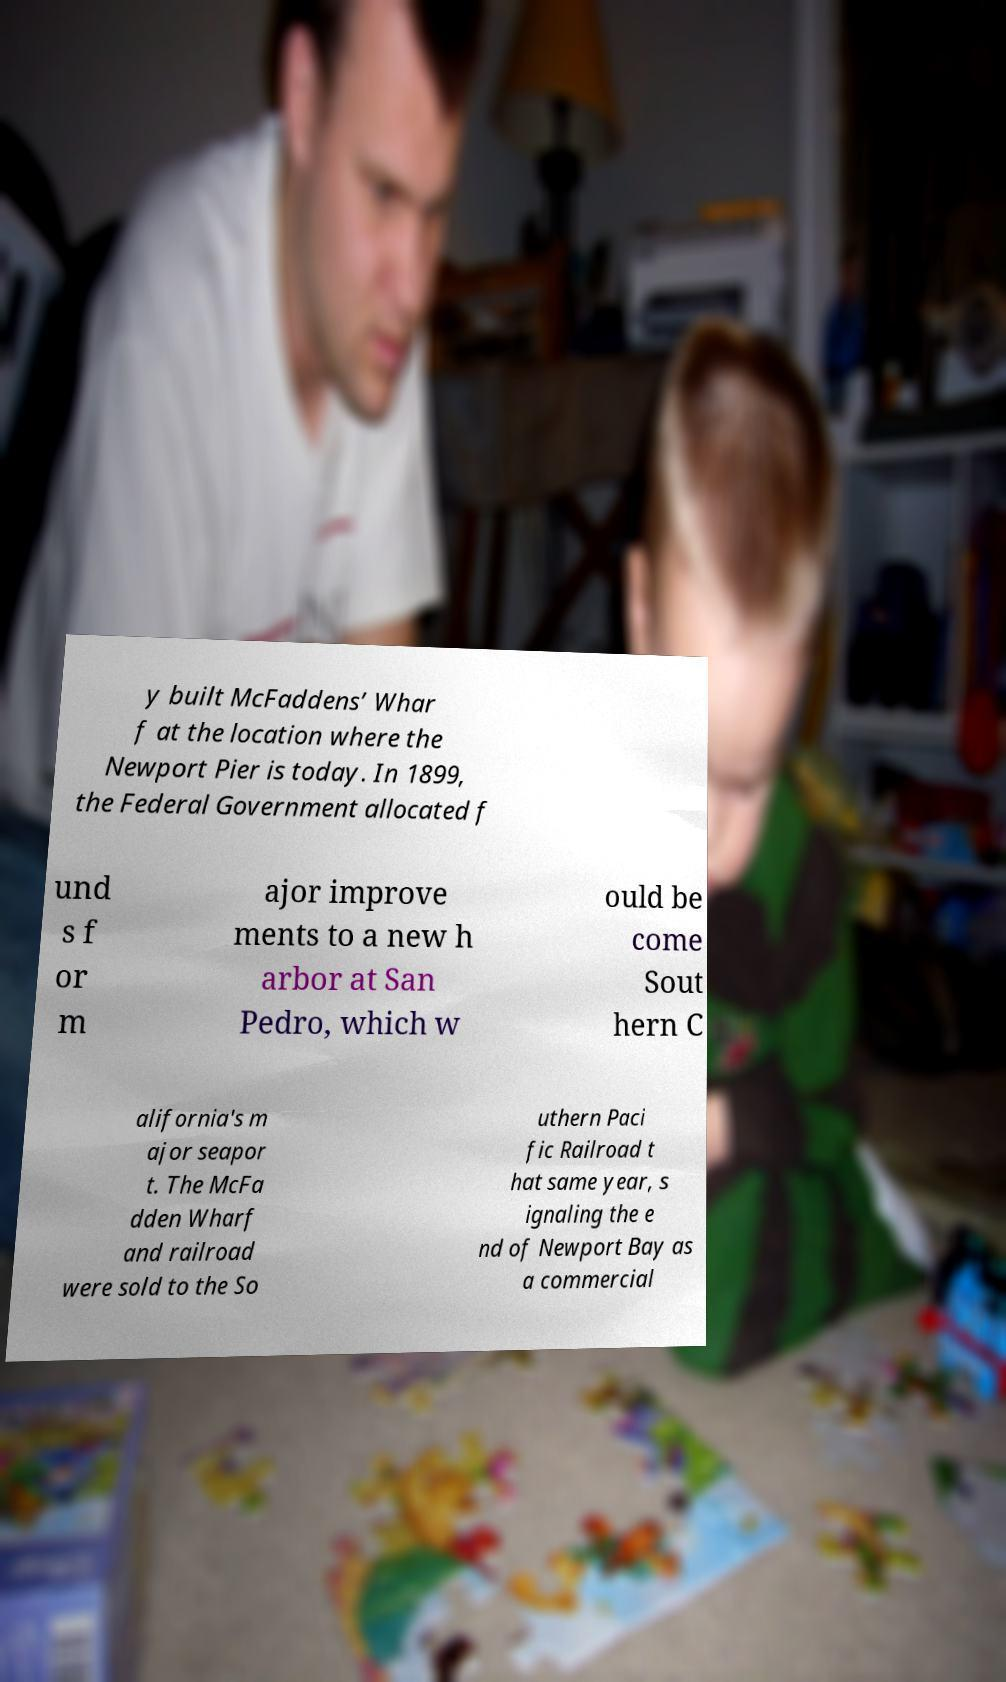There's text embedded in this image that I need extracted. Can you transcribe it verbatim? y built McFaddens’ Whar f at the location where the Newport Pier is today. In 1899, the Federal Government allocated f und s f or m ajor improve ments to a new h arbor at San Pedro, which w ould be come Sout hern C alifornia's m ajor seapor t. The McFa dden Wharf and railroad were sold to the So uthern Paci fic Railroad t hat same year, s ignaling the e nd of Newport Bay as a commercial 